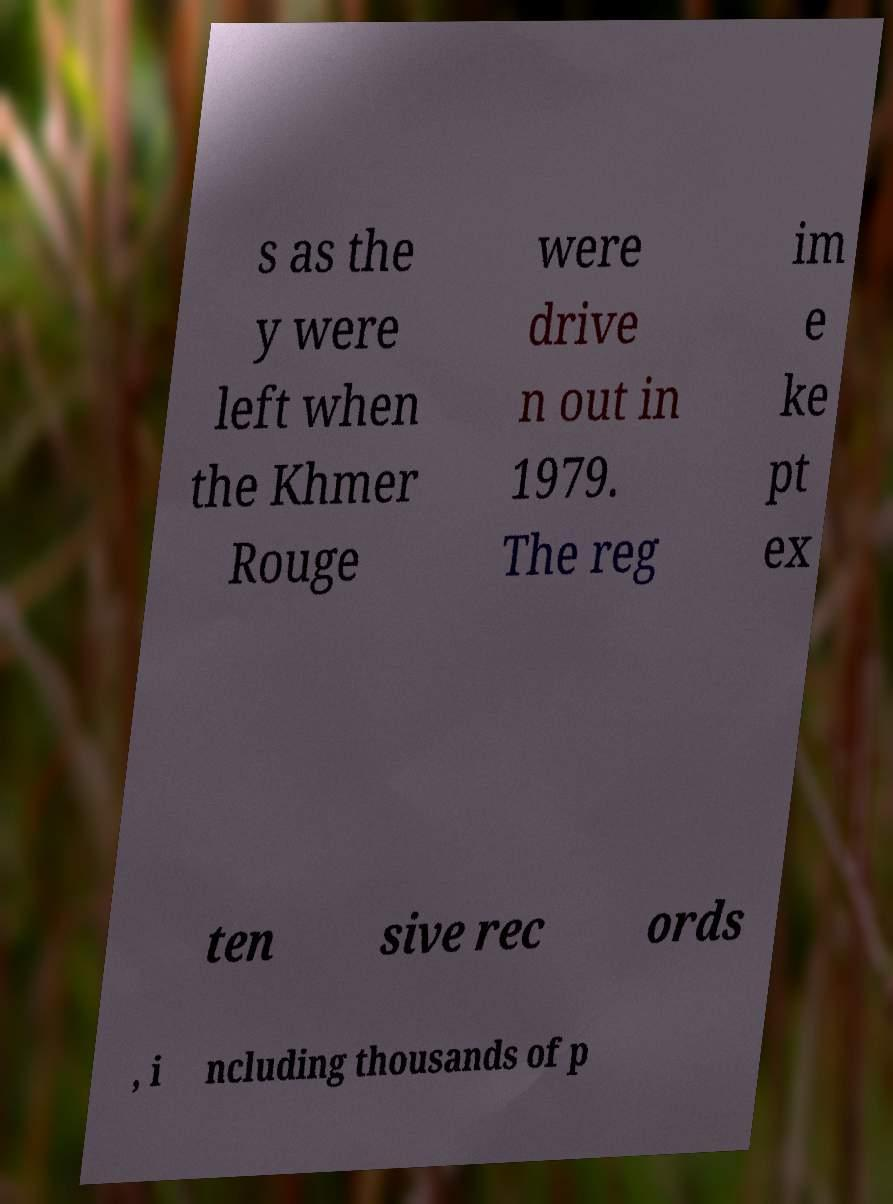For documentation purposes, I need the text within this image transcribed. Could you provide that? s as the y were left when the Khmer Rouge were drive n out in 1979. The reg im e ke pt ex ten sive rec ords , i ncluding thousands of p 